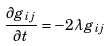Convert formula to latex. <formula><loc_0><loc_0><loc_500><loc_500>\frac { { \partial } g _ { i j } } { { \partial } t } = - 2 \lambda { g _ { i j } }</formula> 